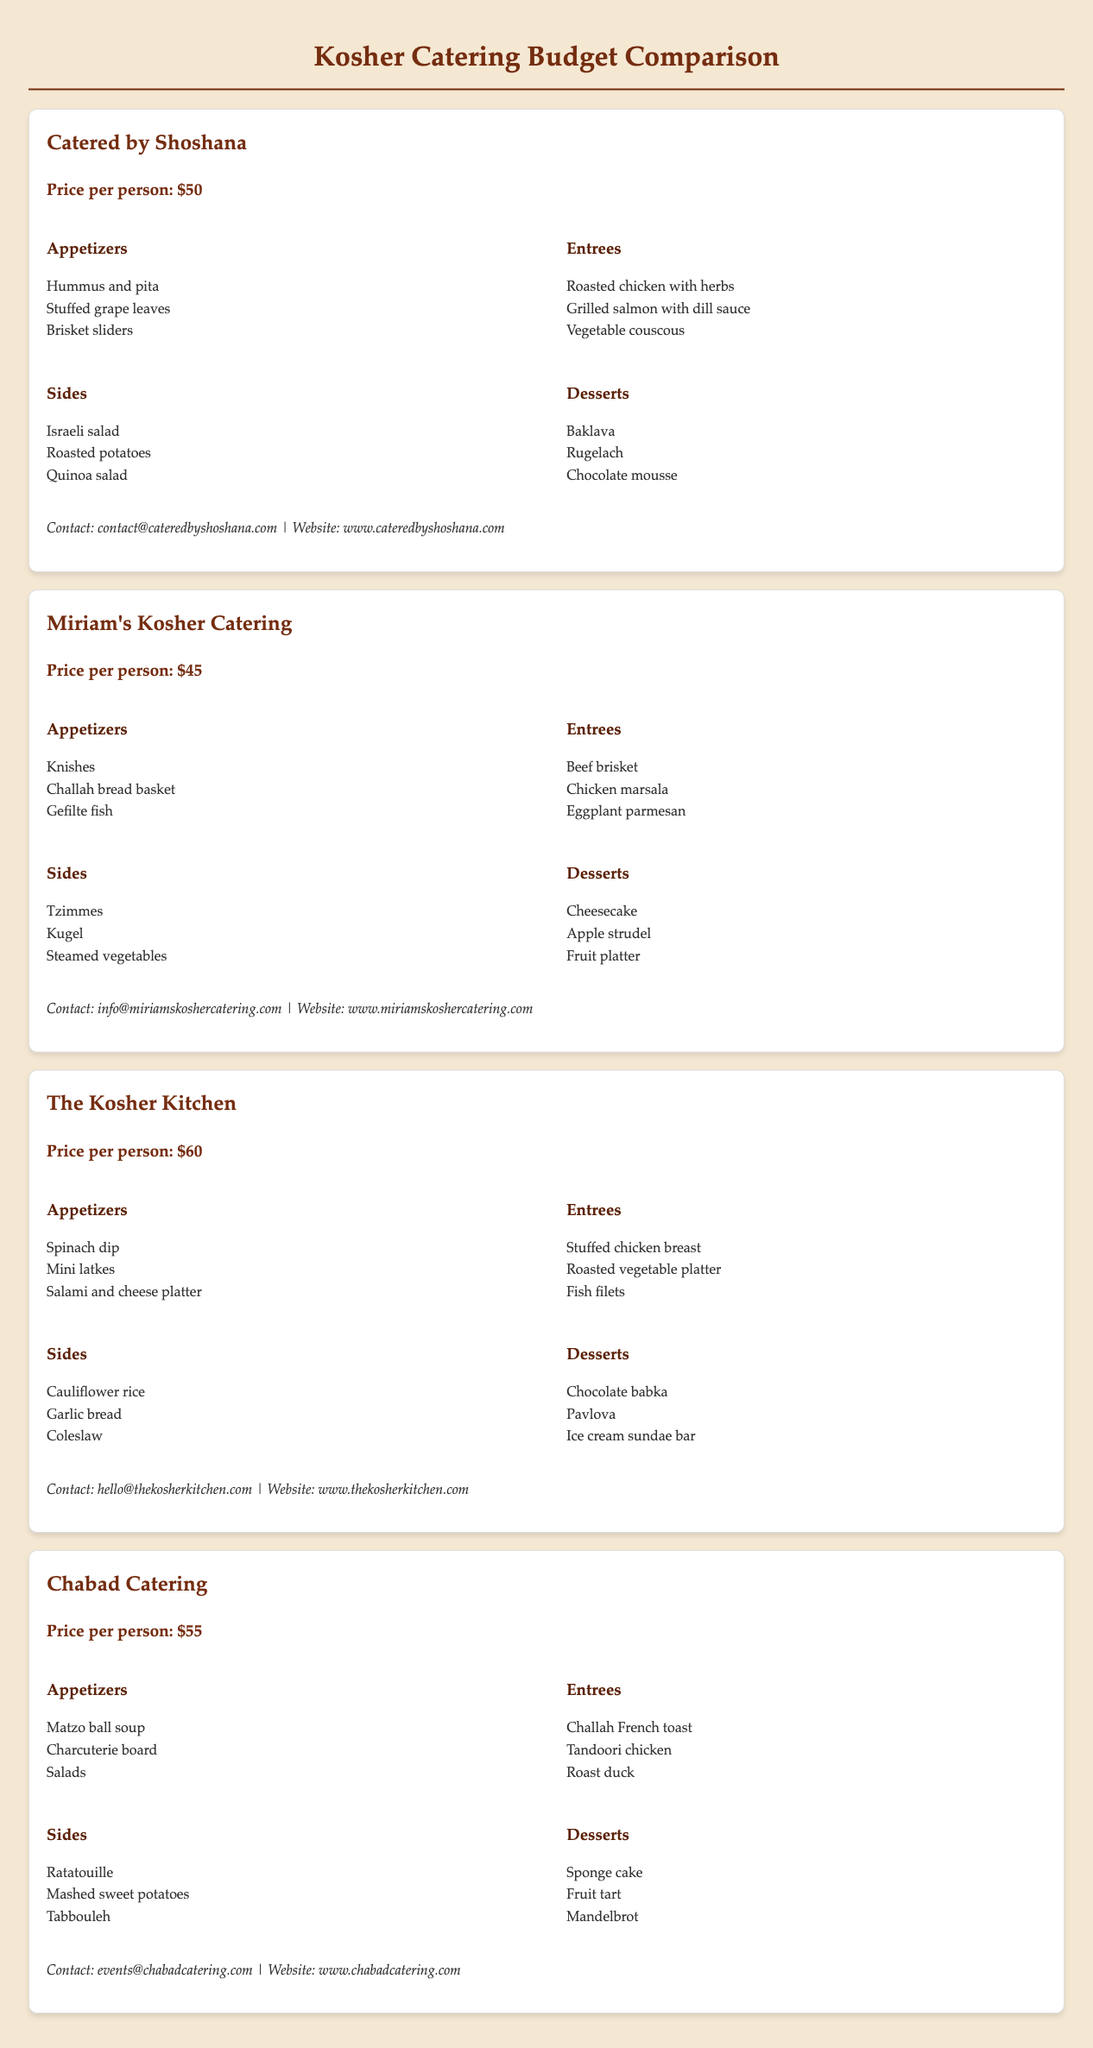What is the price per person for Catered by Shoshana? The price per person for Catered by Shoshana is mentioned directly in the document.
Answer: $50 What is the total number of catering services listed? The document lists multiple catering services. To find the total number, simply count them.
Answer: 4 Which catering service offers the lowest price per person? To find the lowest price, compare all the prices listed in the document.
Answer: Miriam's Kosher Catering What desserts are offered by The Kosher Kitchen? The document lists specific desserts under The Kosher Kitchen section.
Answer: Chocolate babka, Pavlova, Ice cream sundae bar Which catering service has the highest price per person? The highest price per person can be identified by reviewing each service's pricing details.
Answer: The Kosher Kitchen 